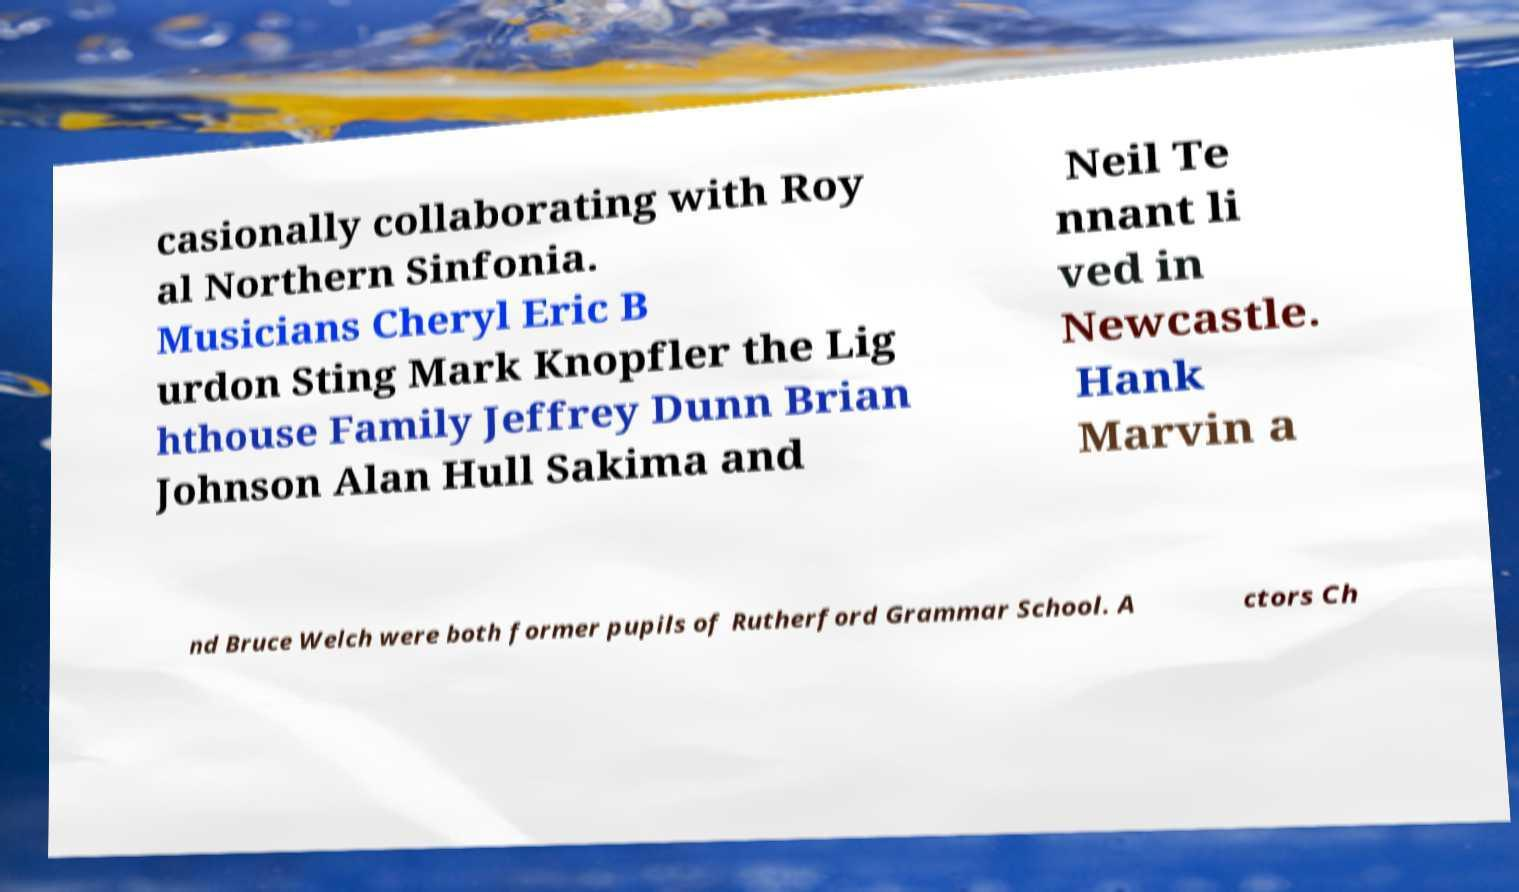Could you extract and type out the text from this image? casionally collaborating with Roy al Northern Sinfonia. Musicians Cheryl Eric B urdon Sting Mark Knopfler the Lig hthouse Family Jeffrey Dunn Brian Johnson Alan Hull Sakima and Neil Te nnant li ved in Newcastle. Hank Marvin a nd Bruce Welch were both former pupils of Rutherford Grammar School. A ctors Ch 